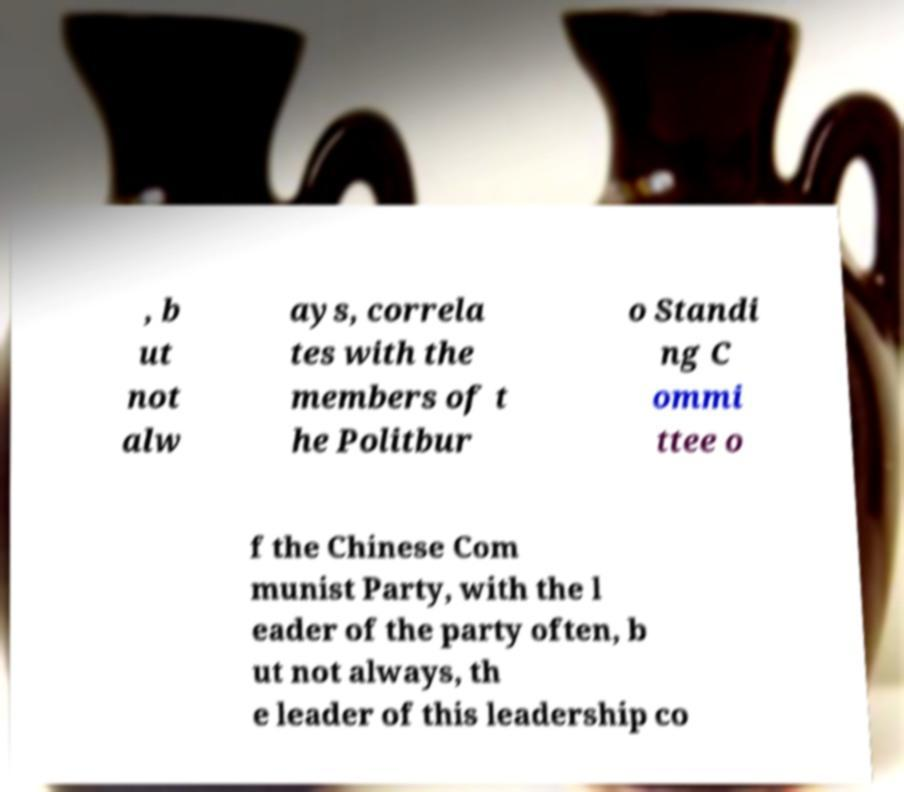There's text embedded in this image that I need extracted. Can you transcribe it verbatim? , b ut not alw ays, correla tes with the members of t he Politbur o Standi ng C ommi ttee o f the Chinese Com munist Party, with the l eader of the party often, b ut not always, th e leader of this leadership co 